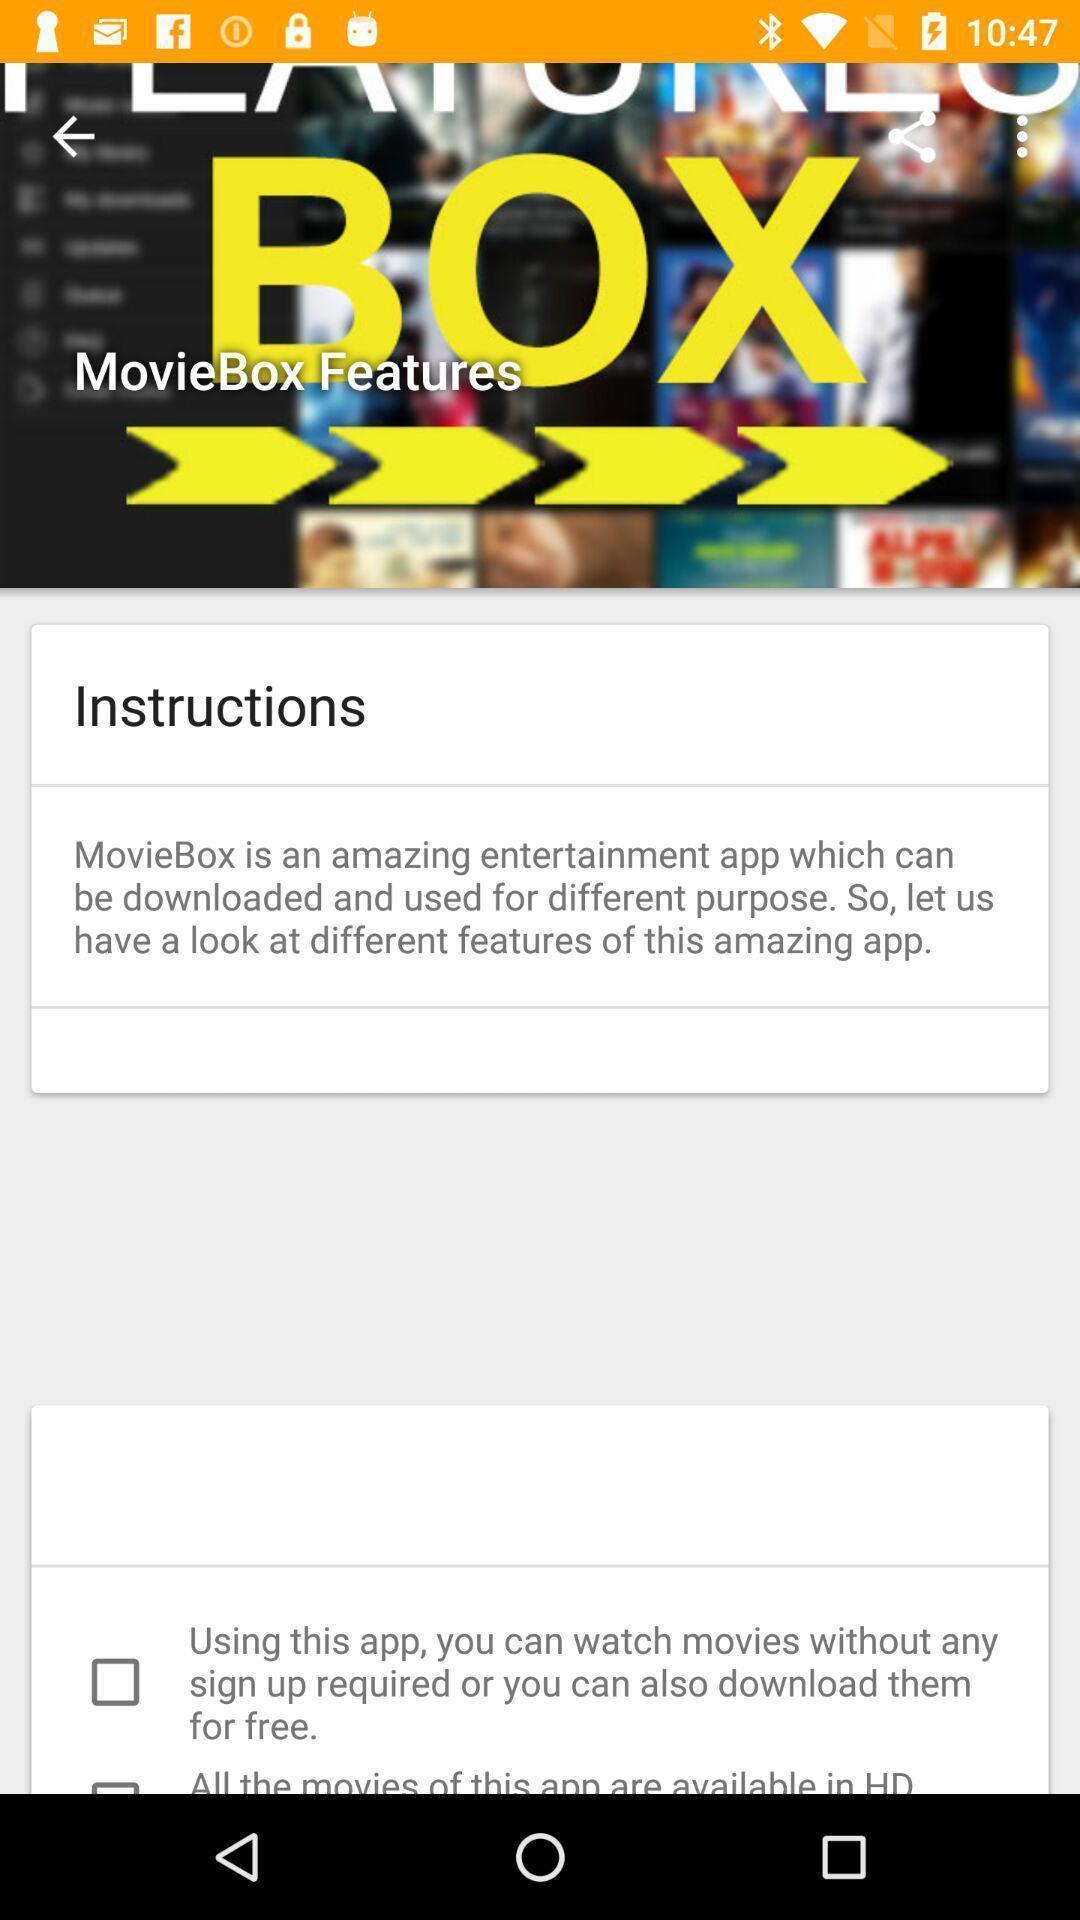Explain what's happening in this screen capture. Screen displaying information about an entertainment application. 